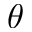<formula> <loc_0><loc_0><loc_500><loc_500>\theta</formula> 